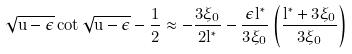Convert formula to latex. <formula><loc_0><loc_0><loc_500><loc_500>\sqrt { u - \tilde { \epsilon } } \cot \sqrt { u - \tilde { \epsilon } } - \frac { 1 } { 2 } \approx - \frac { 3 \xi _ { 0 } } { 2 l ^ { * } } - \frac { \tilde { \epsilon } l ^ { * } } { 3 \xi _ { 0 } } \left ( \frac { l ^ { * } + 3 \xi _ { 0 } } { 3 \xi _ { 0 } } \right )</formula> 